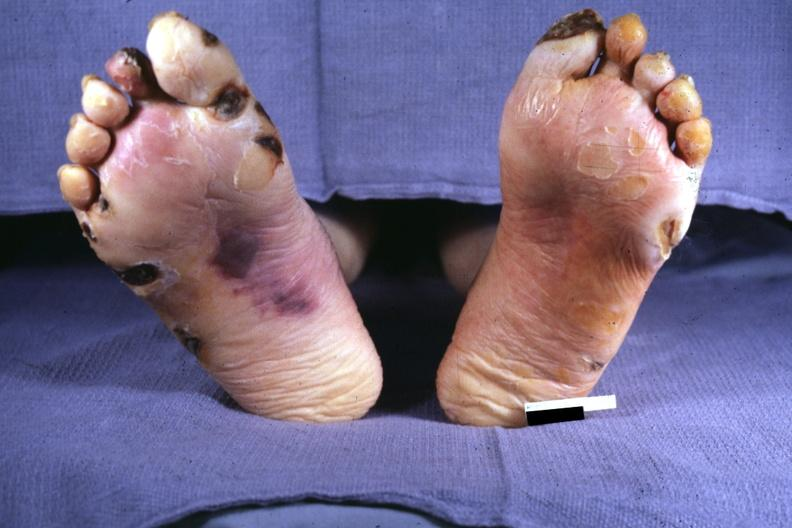s hyalin mass in pituitary which is amyloid there are several slides from this case in this file 23 yowf amyloid limited to brain present?
Answer the question using a single word or phrase. No 